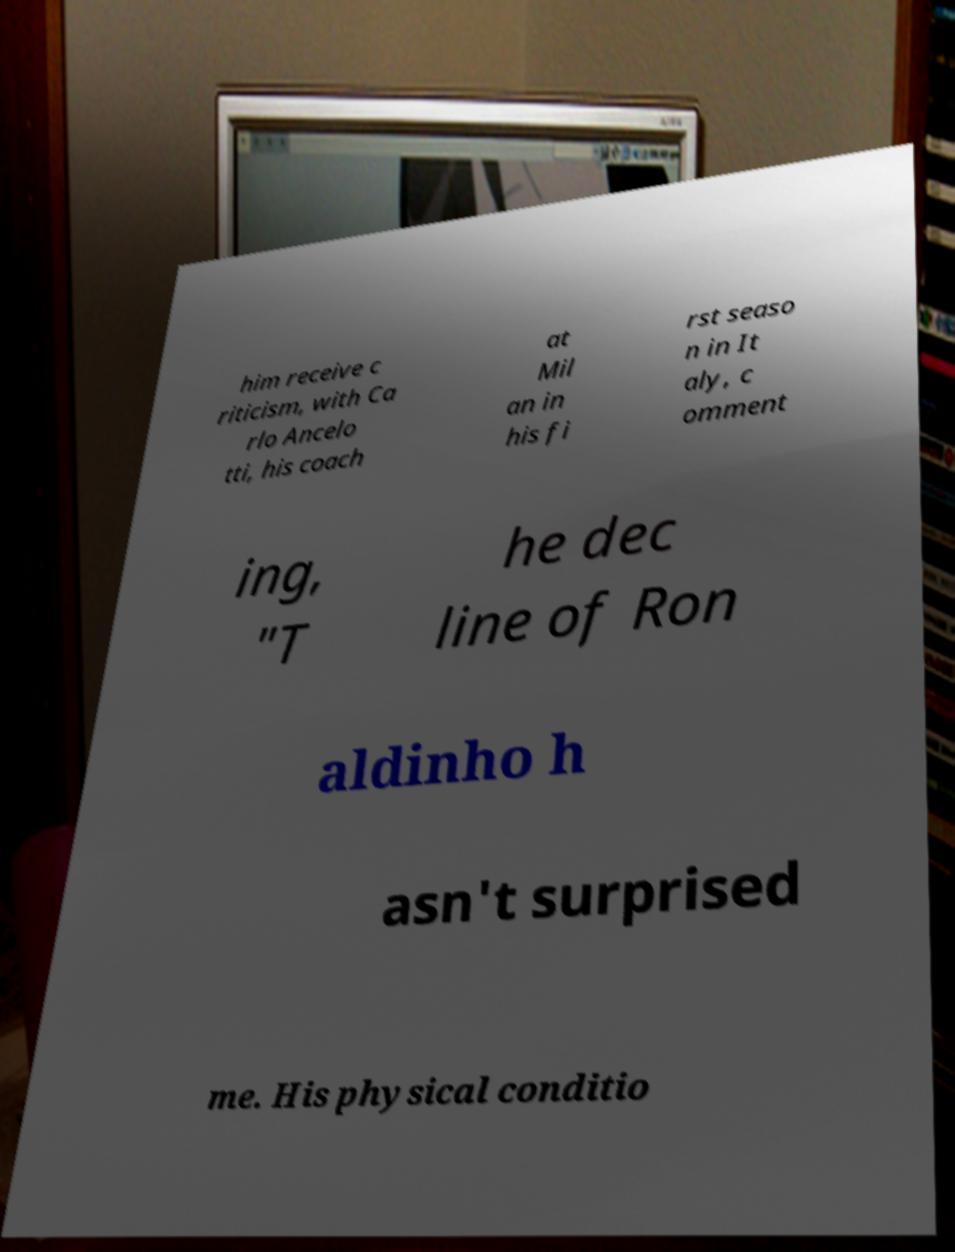What messages or text are displayed in this image? I need them in a readable, typed format. him receive c riticism, with Ca rlo Ancelo tti, his coach at Mil an in his fi rst seaso n in It aly, c omment ing, "T he dec line of Ron aldinho h asn't surprised me. His physical conditio 